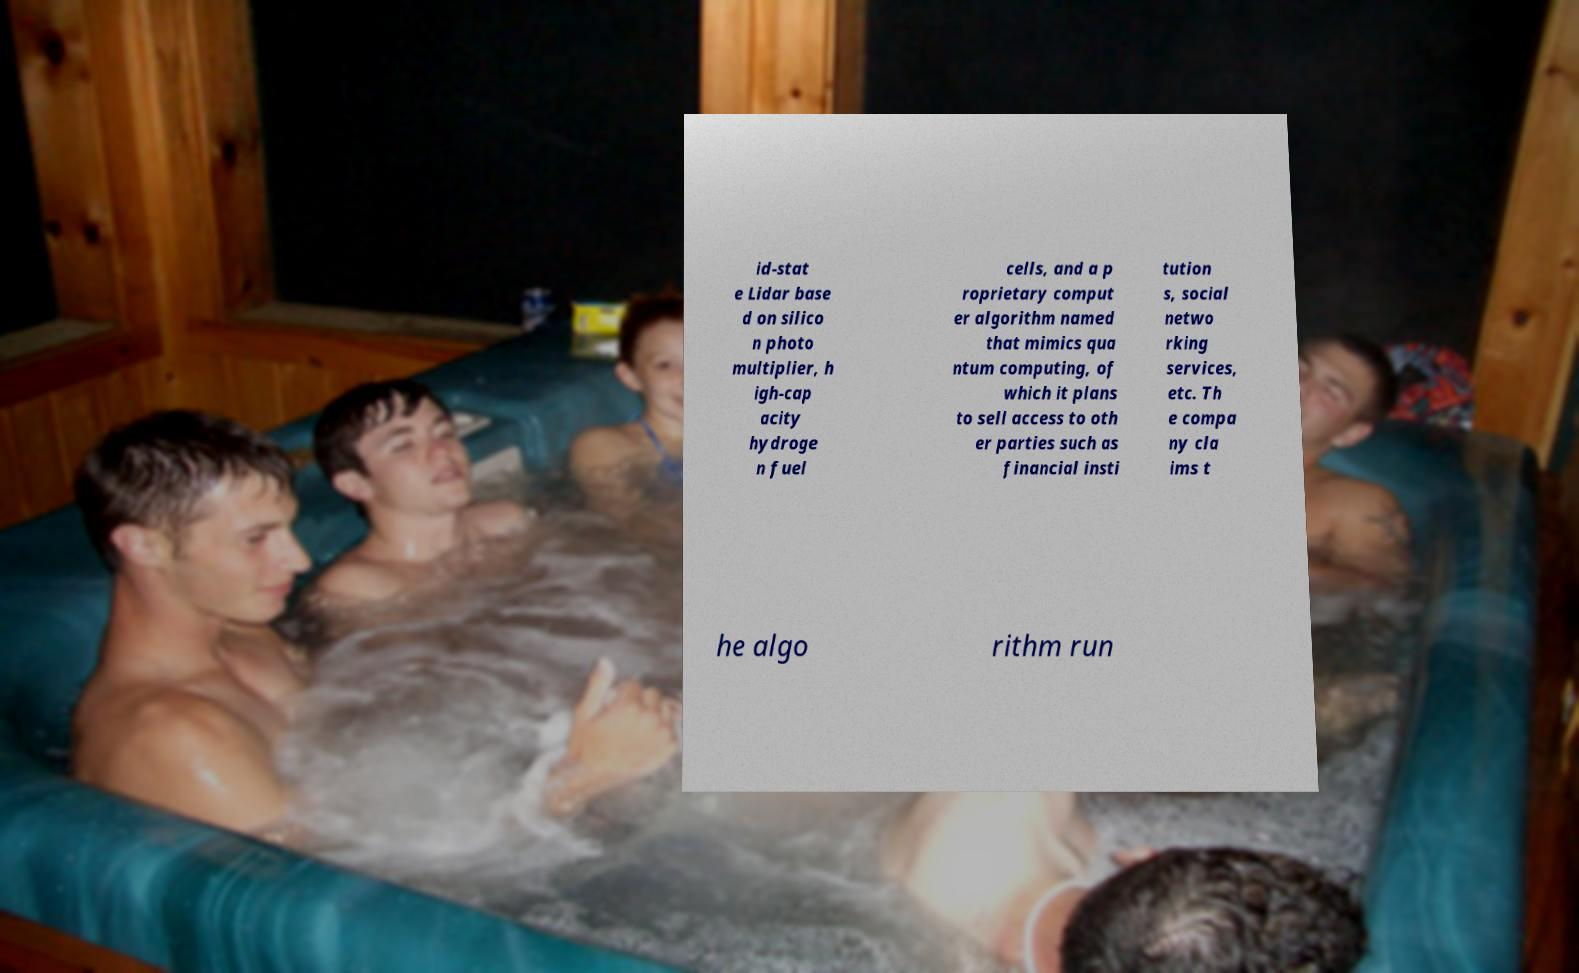Please read and relay the text visible in this image. What does it say? id-stat e Lidar base d on silico n photo multiplier, h igh-cap acity hydroge n fuel cells, and a p roprietary comput er algorithm named that mimics qua ntum computing, of which it plans to sell access to oth er parties such as financial insti tution s, social netwo rking services, etc. Th e compa ny cla ims t he algo rithm run 